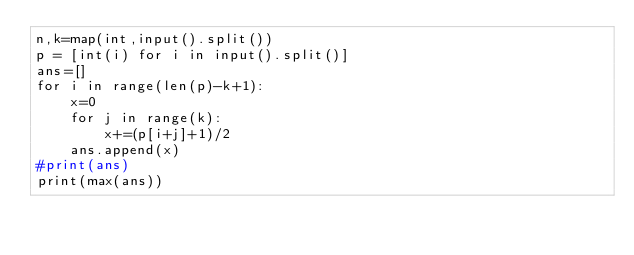<code> <loc_0><loc_0><loc_500><loc_500><_Python_>n,k=map(int,input().split())
p = [int(i) for i in input().split()]
ans=[]
for i in range(len(p)-k+1):
    x=0
    for j in range(k):
        x+=(p[i+j]+1)/2
    ans.append(x)
#print(ans)
print(max(ans))</code> 